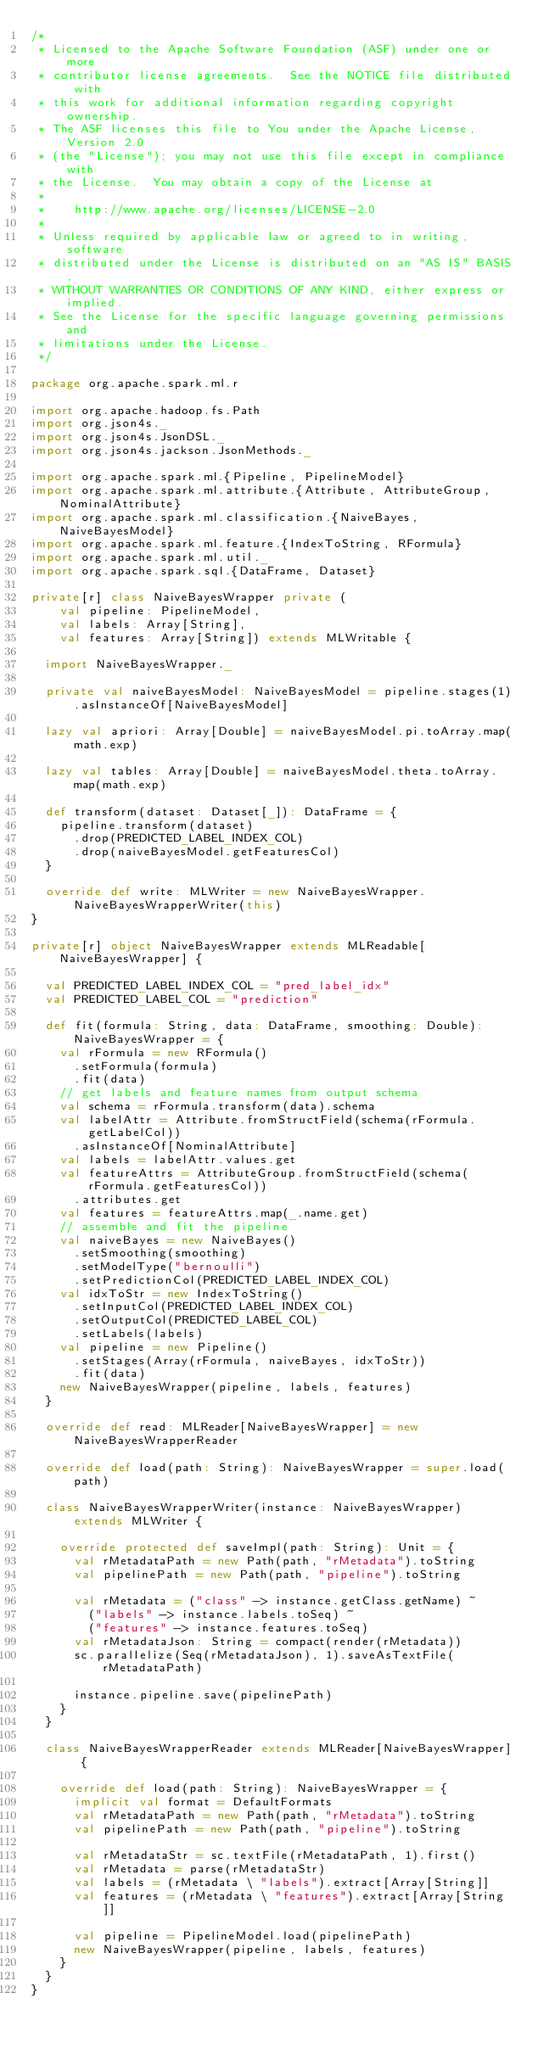<code> <loc_0><loc_0><loc_500><loc_500><_Scala_>/*
 * Licensed to the Apache Software Foundation (ASF) under one or more
 * contributor license agreements.  See the NOTICE file distributed with
 * this work for additional information regarding copyright ownership.
 * The ASF licenses this file to You under the Apache License, Version 2.0
 * (the "License"); you may not use this file except in compliance with
 * the License.  You may obtain a copy of the License at
 *
 *    http://www.apache.org/licenses/LICENSE-2.0
 *
 * Unless required by applicable law or agreed to in writing, software
 * distributed under the License is distributed on an "AS IS" BASIS,
 * WITHOUT WARRANTIES OR CONDITIONS OF ANY KIND, either express or implied.
 * See the License for the specific language governing permissions and
 * limitations under the License.
 */

package org.apache.spark.ml.r

import org.apache.hadoop.fs.Path
import org.json4s._
import org.json4s.JsonDSL._
import org.json4s.jackson.JsonMethods._

import org.apache.spark.ml.{Pipeline, PipelineModel}
import org.apache.spark.ml.attribute.{Attribute, AttributeGroup, NominalAttribute}
import org.apache.spark.ml.classification.{NaiveBayes, NaiveBayesModel}
import org.apache.spark.ml.feature.{IndexToString, RFormula}
import org.apache.spark.ml.util._
import org.apache.spark.sql.{DataFrame, Dataset}

private[r] class NaiveBayesWrapper private (
    val pipeline: PipelineModel,
    val labels: Array[String],
    val features: Array[String]) extends MLWritable {

  import NaiveBayesWrapper._

  private val naiveBayesModel: NaiveBayesModel = pipeline.stages(1).asInstanceOf[NaiveBayesModel]

  lazy val apriori: Array[Double] = naiveBayesModel.pi.toArray.map(math.exp)

  lazy val tables: Array[Double] = naiveBayesModel.theta.toArray.map(math.exp)

  def transform(dataset: Dataset[_]): DataFrame = {
    pipeline.transform(dataset)
      .drop(PREDICTED_LABEL_INDEX_COL)
      .drop(naiveBayesModel.getFeaturesCol)
  }

  override def write: MLWriter = new NaiveBayesWrapper.NaiveBayesWrapperWriter(this)
}

private[r] object NaiveBayesWrapper extends MLReadable[NaiveBayesWrapper] {

  val PREDICTED_LABEL_INDEX_COL = "pred_label_idx"
  val PREDICTED_LABEL_COL = "prediction"

  def fit(formula: String, data: DataFrame, smoothing: Double): NaiveBayesWrapper = {
    val rFormula = new RFormula()
      .setFormula(formula)
      .fit(data)
    // get labels and feature names from output schema
    val schema = rFormula.transform(data).schema
    val labelAttr = Attribute.fromStructField(schema(rFormula.getLabelCol))
      .asInstanceOf[NominalAttribute]
    val labels = labelAttr.values.get
    val featureAttrs = AttributeGroup.fromStructField(schema(rFormula.getFeaturesCol))
      .attributes.get
    val features = featureAttrs.map(_.name.get)
    // assemble and fit the pipeline
    val naiveBayes = new NaiveBayes()
      .setSmoothing(smoothing)
      .setModelType("bernoulli")
      .setPredictionCol(PREDICTED_LABEL_INDEX_COL)
    val idxToStr = new IndexToString()
      .setInputCol(PREDICTED_LABEL_INDEX_COL)
      .setOutputCol(PREDICTED_LABEL_COL)
      .setLabels(labels)
    val pipeline = new Pipeline()
      .setStages(Array(rFormula, naiveBayes, idxToStr))
      .fit(data)
    new NaiveBayesWrapper(pipeline, labels, features)
  }

  override def read: MLReader[NaiveBayesWrapper] = new NaiveBayesWrapperReader

  override def load(path: String): NaiveBayesWrapper = super.load(path)

  class NaiveBayesWrapperWriter(instance: NaiveBayesWrapper) extends MLWriter {

    override protected def saveImpl(path: String): Unit = {
      val rMetadataPath = new Path(path, "rMetadata").toString
      val pipelinePath = new Path(path, "pipeline").toString

      val rMetadata = ("class" -> instance.getClass.getName) ~
        ("labels" -> instance.labels.toSeq) ~
        ("features" -> instance.features.toSeq)
      val rMetadataJson: String = compact(render(rMetadata))
      sc.parallelize(Seq(rMetadataJson), 1).saveAsTextFile(rMetadataPath)

      instance.pipeline.save(pipelinePath)
    }
  }

  class NaiveBayesWrapperReader extends MLReader[NaiveBayesWrapper] {

    override def load(path: String): NaiveBayesWrapper = {
      implicit val format = DefaultFormats
      val rMetadataPath = new Path(path, "rMetadata").toString
      val pipelinePath = new Path(path, "pipeline").toString

      val rMetadataStr = sc.textFile(rMetadataPath, 1).first()
      val rMetadata = parse(rMetadataStr)
      val labels = (rMetadata \ "labels").extract[Array[String]]
      val features = (rMetadata \ "features").extract[Array[String]]

      val pipeline = PipelineModel.load(pipelinePath)
      new NaiveBayesWrapper(pipeline, labels, features)
    }
  }
}
</code> 